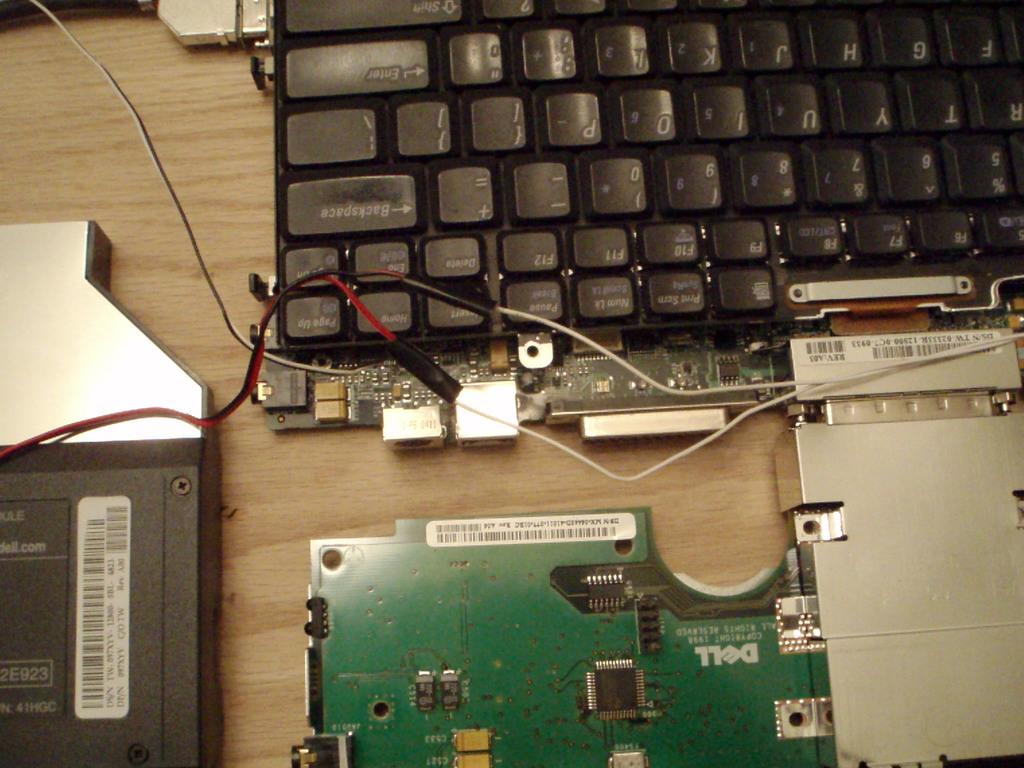What kind of circuit board?
Offer a very short reply. Dell. Are the letters on the keyboard right side up?
Your answer should be very brief. No. 